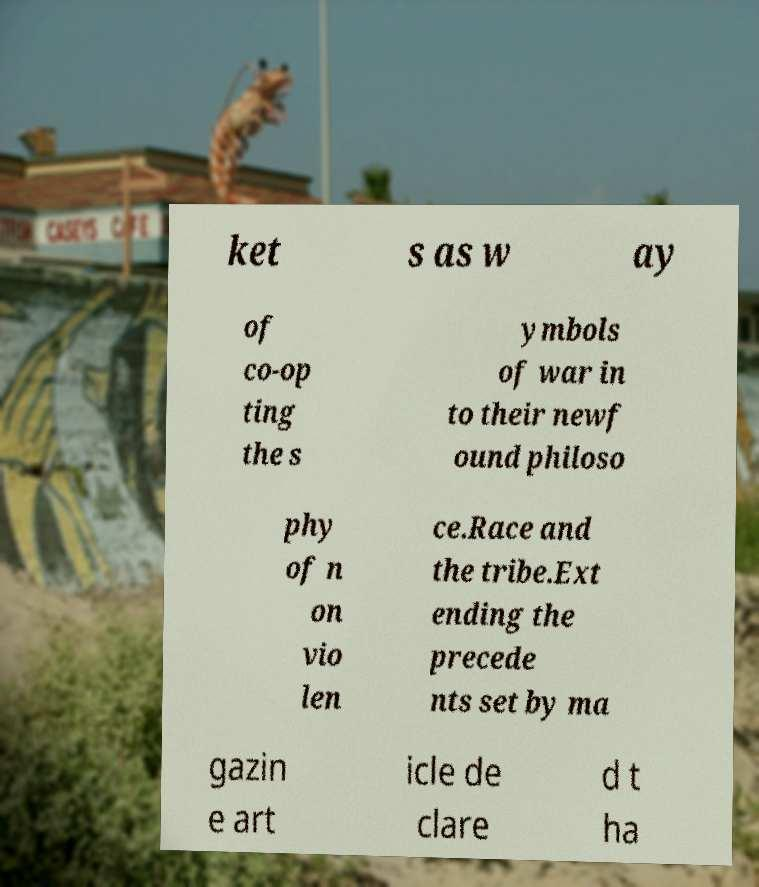Could you extract and type out the text from this image? ket s as w ay of co-op ting the s ymbols of war in to their newf ound philoso phy of n on vio len ce.Race and the tribe.Ext ending the precede nts set by ma gazin e art icle de clare d t ha 